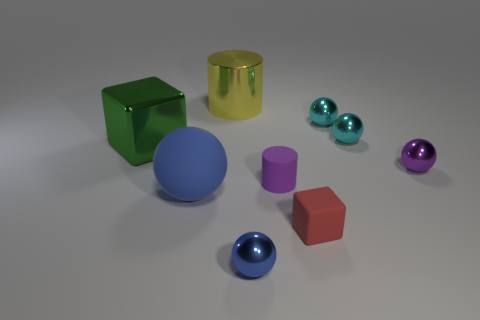Subtract 2 balls. How many balls are left? 3 Subtract all purple spheres. How many spheres are left? 4 Subtract all large spheres. How many spheres are left? 4 Subtract all gray balls. Subtract all brown cylinders. How many balls are left? 5 Subtract all cylinders. How many objects are left? 7 Add 1 tiny matte cylinders. How many tiny matte cylinders are left? 2 Add 4 large cyan objects. How many large cyan objects exist? 4 Subtract 0 cyan cubes. How many objects are left? 9 Subtract all tiny purple metallic spheres. Subtract all big green metallic blocks. How many objects are left? 7 